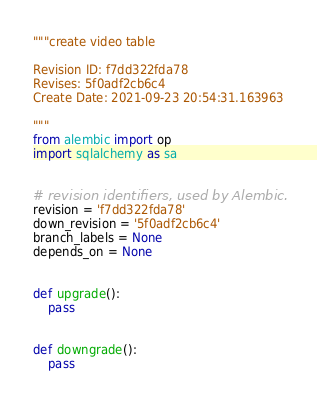<code> <loc_0><loc_0><loc_500><loc_500><_Python_>"""create video table

Revision ID: f7dd322fda78
Revises: 5f0adf2cb6c4
Create Date: 2021-09-23 20:54:31.163963

"""
from alembic import op
import sqlalchemy as sa


# revision identifiers, used by Alembic.
revision = 'f7dd322fda78'
down_revision = '5f0adf2cb6c4'
branch_labels = None
depends_on = None


def upgrade():
    pass


def downgrade():
    pass
</code> 